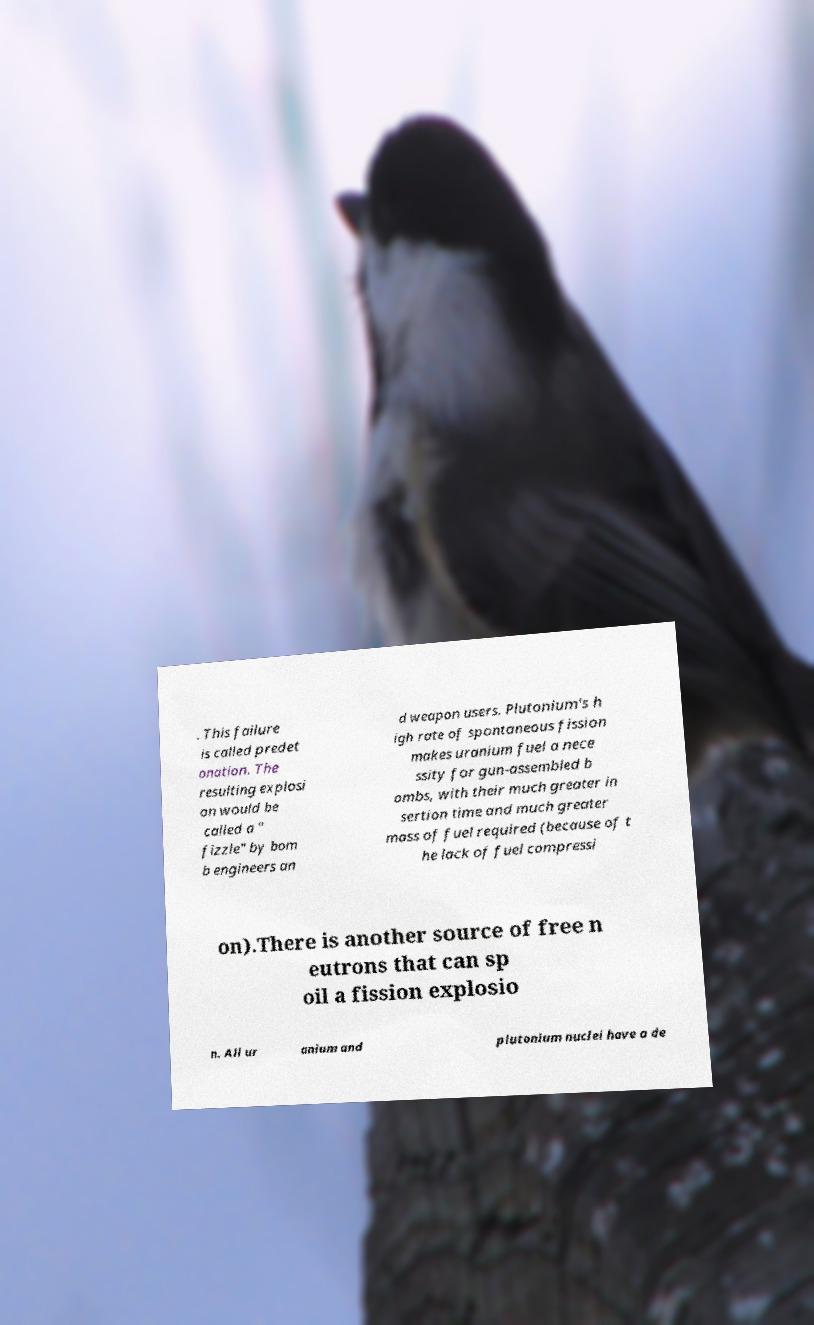Can you accurately transcribe the text from the provided image for me? . This failure is called predet onation. The resulting explosi on would be called a " fizzle" by bom b engineers an d weapon users. Plutonium's h igh rate of spontaneous fission makes uranium fuel a nece ssity for gun-assembled b ombs, with their much greater in sertion time and much greater mass of fuel required (because of t he lack of fuel compressi on).There is another source of free n eutrons that can sp oil a fission explosio n. All ur anium and plutonium nuclei have a de 